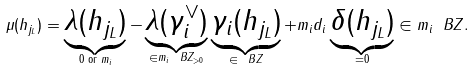Convert formula to latex. <formula><loc_0><loc_0><loc_500><loc_500>\mu ( h _ { j _ { L } } ) = \underbrace { \lambda ( h _ { j _ { L } } ) } _ { 0 \text { or } m _ { i } } - \underbrace { \lambda ( \gamma _ { i } ^ { \vee } ) } _ { \in m _ { i } \ B Z _ { > 0 } } \underbrace { \gamma _ { i } ( h _ { j _ { L } } ) } _ { \in \ B Z } + m _ { i } d _ { i } \underbrace { \delta ( h _ { j _ { L } } ) } _ { = 0 } \in m _ { i } \ B Z .</formula> 